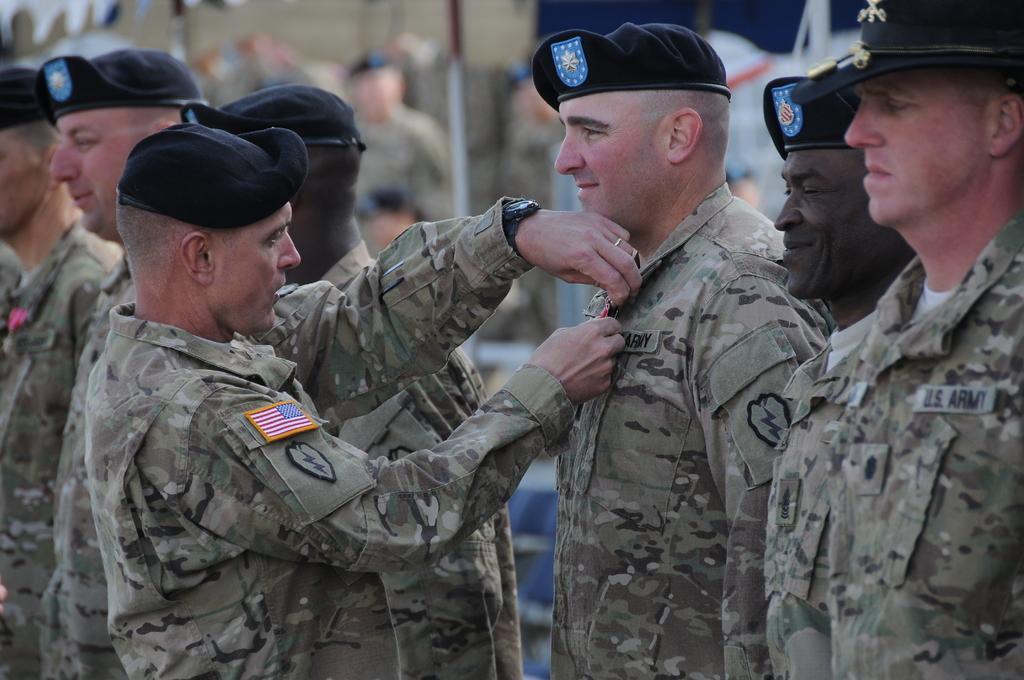Please provide a concise description of this image. In this picture there are group of people standing and there is a person standing and holding the badge. At the back there are group of people and there is a tent and at the bottom there are chairs. 